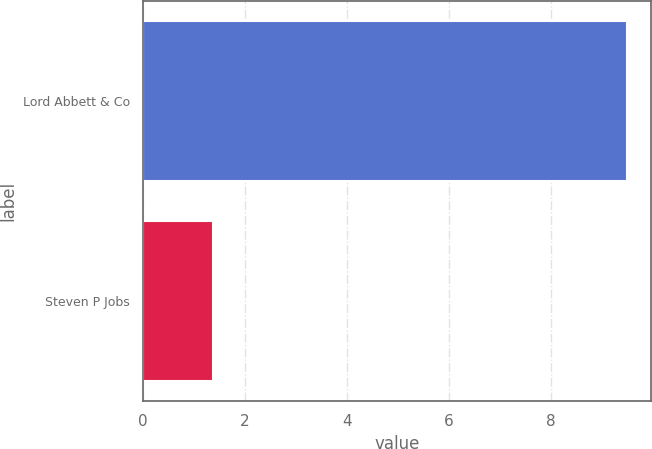Convert chart. <chart><loc_0><loc_0><loc_500><loc_500><bar_chart><fcel>Lord Abbett & Co<fcel>Steven P Jobs<nl><fcel>9.49<fcel>1.38<nl></chart> 